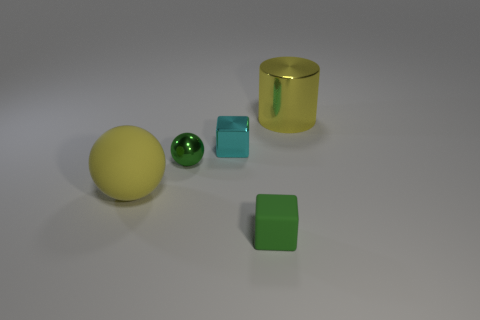Subtract 2 blocks. How many blocks are left? 0 Add 1 yellow matte spheres. How many objects exist? 6 Subtract all cubes. How many objects are left? 3 Subtract 1 yellow cylinders. How many objects are left? 4 Subtract all yellow blocks. Subtract all purple spheres. How many blocks are left? 2 Subtract all cylinders. Subtract all cyan cubes. How many objects are left? 3 Add 2 big metal things. How many big metal things are left? 3 Add 1 small green cubes. How many small green cubes exist? 2 